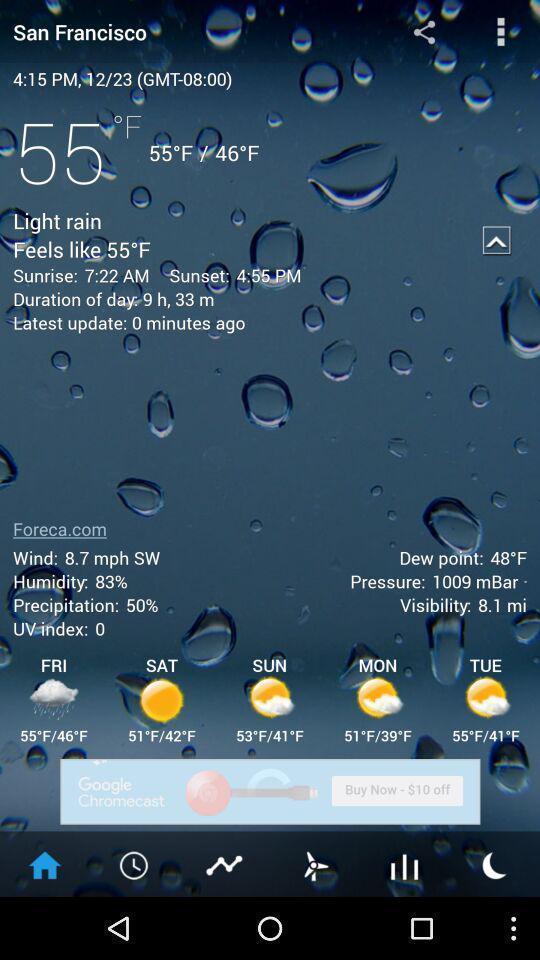Explain the elements present in this screenshot. Page showing weather conditions on app. 